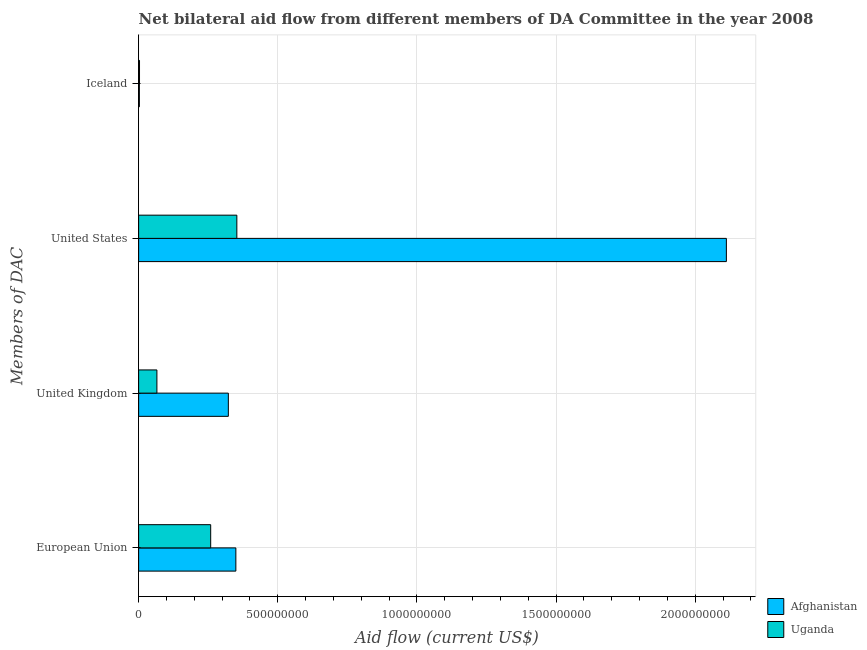How many different coloured bars are there?
Your answer should be very brief. 2. Are the number of bars per tick equal to the number of legend labels?
Provide a succinct answer. Yes. How many bars are there on the 1st tick from the top?
Your answer should be very brief. 2. How many bars are there on the 4th tick from the bottom?
Keep it short and to the point. 2. What is the label of the 2nd group of bars from the top?
Offer a terse response. United States. What is the amount of aid given by eu in Uganda?
Provide a short and direct response. 2.59e+08. Across all countries, what is the maximum amount of aid given by uk?
Give a very brief answer. 3.22e+08. Across all countries, what is the minimum amount of aid given by uk?
Your answer should be compact. 6.57e+07. In which country was the amount of aid given by us maximum?
Make the answer very short. Afghanistan. In which country was the amount of aid given by uk minimum?
Ensure brevity in your answer.  Uganda. What is the total amount of aid given by iceland in the graph?
Offer a terse response. 5.88e+06. What is the difference between the amount of aid given by uk in Afghanistan and that in Uganda?
Keep it short and to the point. 2.57e+08. What is the difference between the amount of aid given by us in Afghanistan and the amount of aid given by iceland in Uganda?
Make the answer very short. 2.11e+09. What is the average amount of aid given by eu per country?
Make the answer very short. 3.04e+08. What is the difference between the amount of aid given by eu and amount of aid given by iceland in Afghanistan?
Keep it short and to the point. 3.47e+08. In how many countries, is the amount of aid given by eu greater than 700000000 US$?
Make the answer very short. 0. What is the ratio of the amount of aid given by eu in Uganda to that in Afghanistan?
Ensure brevity in your answer.  0.74. Is the amount of aid given by uk in Afghanistan less than that in Uganda?
Provide a short and direct response. No. What is the difference between the highest and the second highest amount of aid given by eu?
Provide a short and direct response. 9.04e+07. What is the difference between the highest and the lowest amount of aid given by eu?
Ensure brevity in your answer.  9.04e+07. In how many countries, is the amount of aid given by eu greater than the average amount of aid given by eu taken over all countries?
Offer a terse response. 1. Is it the case that in every country, the sum of the amount of aid given by us and amount of aid given by iceland is greater than the sum of amount of aid given by uk and amount of aid given by eu?
Provide a succinct answer. No. What does the 2nd bar from the top in United Kingdom represents?
Your answer should be very brief. Afghanistan. What does the 2nd bar from the bottom in United Kingdom represents?
Your answer should be compact. Uganda. Is it the case that in every country, the sum of the amount of aid given by eu and amount of aid given by uk is greater than the amount of aid given by us?
Keep it short and to the point. No. How many bars are there?
Offer a very short reply. 8. What is the difference between two consecutive major ticks on the X-axis?
Keep it short and to the point. 5.00e+08. How many legend labels are there?
Keep it short and to the point. 2. How are the legend labels stacked?
Your answer should be compact. Vertical. What is the title of the graph?
Keep it short and to the point. Net bilateral aid flow from different members of DA Committee in the year 2008. What is the label or title of the X-axis?
Provide a short and direct response. Aid flow (current US$). What is the label or title of the Y-axis?
Make the answer very short. Members of DAC. What is the Aid flow (current US$) in Afghanistan in European Union?
Offer a very short reply. 3.49e+08. What is the Aid flow (current US$) in Uganda in European Union?
Provide a succinct answer. 2.59e+08. What is the Aid flow (current US$) of Afghanistan in United Kingdom?
Keep it short and to the point. 3.22e+08. What is the Aid flow (current US$) of Uganda in United Kingdom?
Your answer should be very brief. 6.57e+07. What is the Aid flow (current US$) in Afghanistan in United States?
Provide a succinct answer. 2.11e+09. What is the Aid flow (current US$) in Uganda in United States?
Your answer should be very brief. 3.53e+08. What is the Aid flow (current US$) of Afghanistan in Iceland?
Your answer should be very brief. 2.68e+06. What is the Aid flow (current US$) in Uganda in Iceland?
Your answer should be very brief. 3.20e+06. Across all Members of DAC, what is the maximum Aid flow (current US$) in Afghanistan?
Your answer should be very brief. 2.11e+09. Across all Members of DAC, what is the maximum Aid flow (current US$) in Uganda?
Ensure brevity in your answer.  3.53e+08. Across all Members of DAC, what is the minimum Aid flow (current US$) of Afghanistan?
Make the answer very short. 2.68e+06. Across all Members of DAC, what is the minimum Aid flow (current US$) in Uganda?
Your answer should be compact. 3.20e+06. What is the total Aid flow (current US$) in Afghanistan in the graph?
Give a very brief answer. 2.79e+09. What is the total Aid flow (current US$) of Uganda in the graph?
Provide a succinct answer. 6.81e+08. What is the difference between the Aid flow (current US$) in Afghanistan in European Union and that in United Kingdom?
Provide a short and direct response. 2.70e+07. What is the difference between the Aid flow (current US$) in Uganda in European Union and that in United Kingdom?
Give a very brief answer. 1.93e+08. What is the difference between the Aid flow (current US$) of Afghanistan in European Union and that in United States?
Provide a succinct answer. -1.76e+09. What is the difference between the Aid flow (current US$) in Uganda in European Union and that in United States?
Your answer should be very brief. -9.40e+07. What is the difference between the Aid flow (current US$) of Afghanistan in European Union and that in Iceland?
Your answer should be compact. 3.47e+08. What is the difference between the Aid flow (current US$) of Uganda in European Union and that in Iceland?
Keep it short and to the point. 2.56e+08. What is the difference between the Aid flow (current US$) of Afghanistan in United Kingdom and that in United States?
Your answer should be very brief. -1.79e+09. What is the difference between the Aid flow (current US$) in Uganda in United Kingdom and that in United States?
Your answer should be very brief. -2.87e+08. What is the difference between the Aid flow (current US$) in Afghanistan in United Kingdom and that in Iceland?
Provide a succinct answer. 3.20e+08. What is the difference between the Aid flow (current US$) of Uganda in United Kingdom and that in Iceland?
Your response must be concise. 6.25e+07. What is the difference between the Aid flow (current US$) in Afghanistan in United States and that in Iceland?
Make the answer very short. 2.11e+09. What is the difference between the Aid flow (current US$) of Uganda in United States and that in Iceland?
Provide a short and direct response. 3.50e+08. What is the difference between the Aid flow (current US$) of Afghanistan in European Union and the Aid flow (current US$) of Uganda in United Kingdom?
Provide a short and direct response. 2.84e+08. What is the difference between the Aid flow (current US$) of Afghanistan in European Union and the Aid flow (current US$) of Uganda in United States?
Offer a very short reply. -3.57e+06. What is the difference between the Aid flow (current US$) of Afghanistan in European Union and the Aid flow (current US$) of Uganda in Iceland?
Offer a very short reply. 3.46e+08. What is the difference between the Aid flow (current US$) in Afghanistan in United Kingdom and the Aid flow (current US$) in Uganda in United States?
Your answer should be very brief. -3.06e+07. What is the difference between the Aid flow (current US$) of Afghanistan in United Kingdom and the Aid flow (current US$) of Uganda in Iceland?
Provide a succinct answer. 3.19e+08. What is the difference between the Aid flow (current US$) of Afghanistan in United States and the Aid flow (current US$) of Uganda in Iceland?
Give a very brief answer. 2.11e+09. What is the average Aid flow (current US$) of Afghanistan per Members of DAC?
Make the answer very short. 6.96e+08. What is the average Aid flow (current US$) in Uganda per Members of DAC?
Your answer should be compact. 1.70e+08. What is the difference between the Aid flow (current US$) of Afghanistan and Aid flow (current US$) of Uganda in European Union?
Offer a very short reply. 9.04e+07. What is the difference between the Aid flow (current US$) of Afghanistan and Aid flow (current US$) of Uganda in United Kingdom?
Provide a succinct answer. 2.57e+08. What is the difference between the Aid flow (current US$) in Afghanistan and Aid flow (current US$) in Uganda in United States?
Provide a short and direct response. 1.76e+09. What is the difference between the Aid flow (current US$) of Afghanistan and Aid flow (current US$) of Uganda in Iceland?
Your answer should be very brief. -5.20e+05. What is the ratio of the Aid flow (current US$) of Afghanistan in European Union to that in United Kingdom?
Your answer should be compact. 1.08. What is the ratio of the Aid flow (current US$) of Uganda in European Union to that in United Kingdom?
Provide a short and direct response. 3.94. What is the ratio of the Aid flow (current US$) in Afghanistan in European Union to that in United States?
Your answer should be very brief. 0.17. What is the ratio of the Aid flow (current US$) of Uganda in European Union to that in United States?
Your answer should be compact. 0.73. What is the ratio of the Aid flow (current US$) in Afghanistan in European Union to that in Iceland?
Your answer should be very brief. 130.34. What is the ratio of the Aid flow (current US$) in Uganda in European Union to that in Iceland?
Give a very brief answer. 80.9. What is the ratio of the Aid flow (current US$) of Afghanistan in United Kingdom to that in United States?
Provide a short and direct response. 0.15. What is the ratio of the Aid flow (current US$) of Uganda in United Kingdom to that in United States?
Your answer should be very brief. 0.19. What is the ratio of the Aid flow (current US$) in Afghanistan in United Kingdom to that in Iceland?
Ensure brevity in your answer.  120.26. What is the ratio of the Aid flow (current US$) in Uganda in United Kingdom to that in Iceland?
Make the answer very short. 20.52. What is the ratio of the Aid flow (current US$) of Afghanistan in United States to that in Iceland?
Provide a succinct answer. 787.9. What is the ratio of the Aid flow (current US$) in Uganda in United States to that in Iceland?
Your answer should be compact. 110.28. What is the difference between the highest and the second highest Aid flow (current US$) in Afghanistan?
Offer a very short reply. 1.76e+09. What is the difference between the highest and the second highest Aid flow (current US$) of Uganda?
Your answer should be very brief. 9.40e+07. What is the difference between the highest and the lowest Aid flow (current US$) of Afghanistan?
Offer a very short reply. 2.11e+09. What is the difference between the highest and the lowest Aid flow (current US$) in Uganda?
Give a very brief answer. 3.50e+08. 